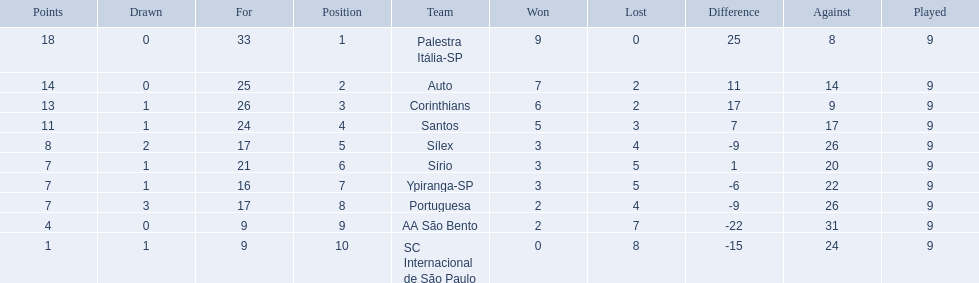What were all the teams that competed in 1926 brazilian football? Palestra Itália-SP, Auto, Corinthians, Santos, Sílex, Sírio, Ypiranga-SP, Portuguesa, AA São Bento, SC Internacional de São Paulo. Which of these had zero games lost? Palestra Itália-SP. 